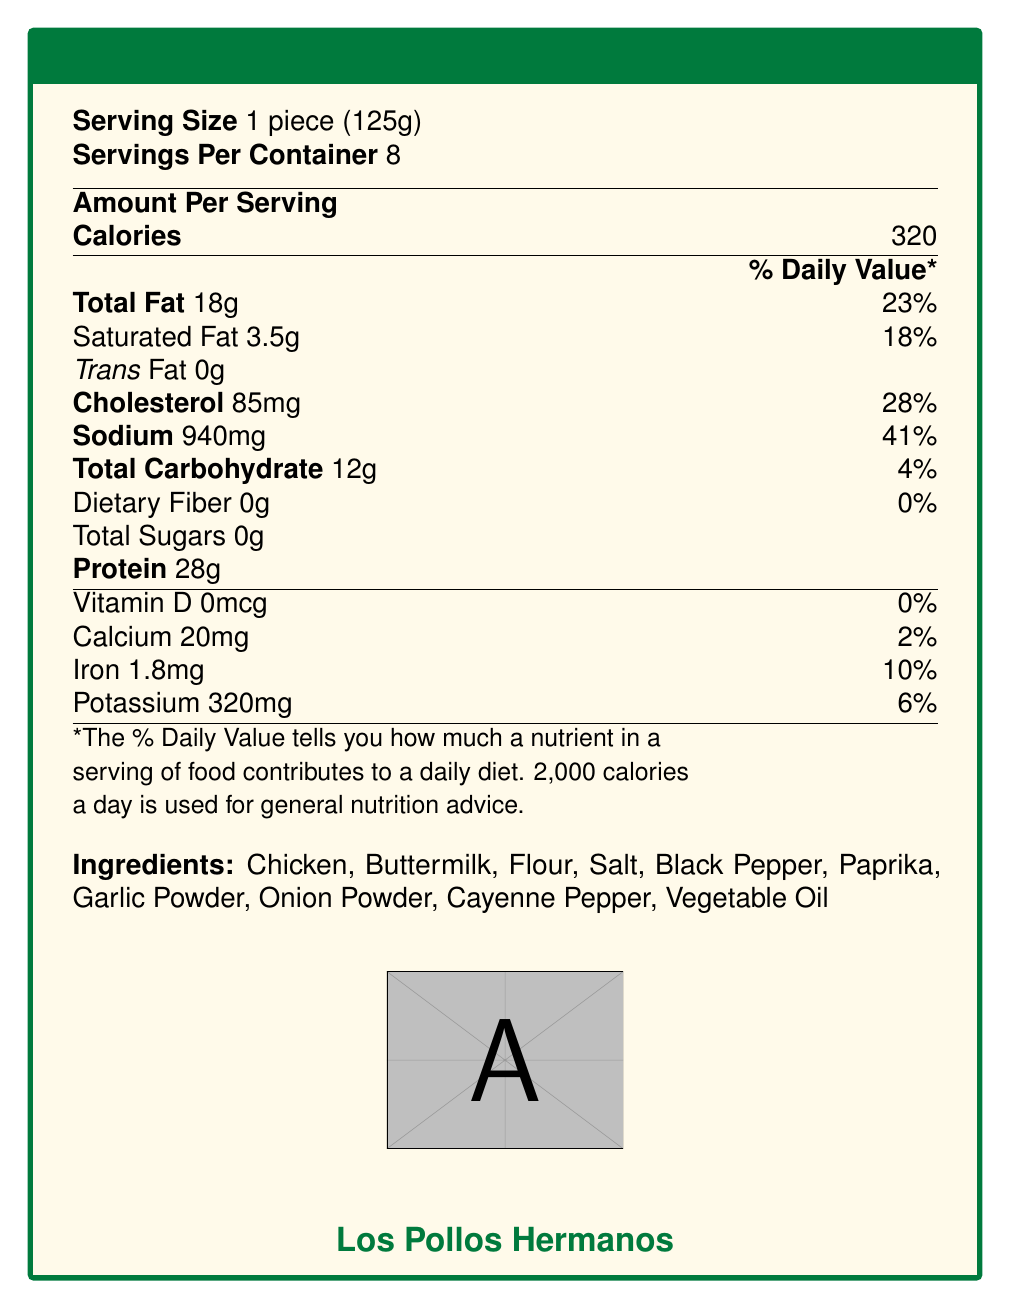What is the serving size mentioned in the document? The document specifies that the serving size is 1 piece (125g).
Answer: 1 piece (125g) How many servings per container are there? The document clearly states that there are 8 servings per container.
Answer: 8 What is the total fat content per serving and its percentage of the daily value? The document lists the total fat content as 18g per serving, which is 23% of the daily value.
Answer: 18g, 23% How much cholesterol is in one serving of the fried chicken? The document notes that one serving contains 85mg of cholesterol.
Answer: 85mg How does the sodium content per serving compare to the daily value percentage? The sodium content is 940mg per serving, which is 41% of the daily value.
Answer: 41% What is the protein content in one serving? The document states that the protein content per serving is 28g.
Answer: 28g How many grams of trans fat are in one serving? The document indicates that there are 0g of trans fat in one serving.
Answer: 0g Which of the following ingredients is NOT in the fried chicken? A. Garlic Powder B. Preservatives C. Cayenne Pepper D. Buttermilk The listed ingredients are Chicken, Buttermilk, Flour, Salt, Black Pepper, Paprika, Garlic Powder, Onion Powder, Cayenne Pepper, and Vegetable Oil. Preservatives are not mentioned.
Answer: B What vitamin is present in the smallest amount or not at all in the chicken? A. Vitamin D B. Calcium C. Iron D. Potassium The document shows that Vitamin D is 0mcg, which is 0% of the daily value.
Answer: A Does the total carbohydrate in one serving exceed 20% of the daily value? Yes/No The document states that the total carbohydrate is 12g, which is only 4% of the daily value.
Answer: No Summarize the main content of the Nutrition Facts Label for Los Pollos Hermanos' signature fried chicken. This summary captures the essential elements of the nutrition facts, including serving size, servings per container, calorie count, major nutritional values, and ingredients.
Answer: The document provides the nutrition facts for Los Pollos Hermanos' signature fried chicken, indicating a serving size of 1 piece (125g) with 8 servings per container. Key nutritional elements include 320 calories, 18g of total fat (23% daily value), 85mg of cholesterol (28% daily value), 940mg of sodium (41% daily value), 12g of total carbohydrate (4% daily value), and 28g of protein. The ingredients listed are Chicken, Buttermilk, Flour, Salt, Black Pepper, Paprika, Garlic Powder, Onion Powder, Cayenne Pepper, and Vegetable Oil. How many milligrams of calcium are in one serving? According to the document, there are 20mg of calcium per serving.
Answer: 20mg What aspect of Gus Fring's character is reflected in the meticulous nutrition facts of the fried chicken? The document notes that the meticulous nutrition information reflects Gus Fring's methodical approach to both his legitimate and illegal businesses.
Answer: Calculation and attention to detail What is the golden-brown hue of the fried chicken intended to symbolize in the cinematography of the show? The document mentions that the golden-brown hue of the fried chicken mirrors the show's iconic desert landscapes and signifies the tension and duality of Gus Fring's character.
Answer: The golden-brown hue symbolizes the desert landscapes and the duality of Gus Fring's character. What is the relationship between the seemingly wholesome product and the illegal activities it conceals? The document indicates that the wholesome nature of the fried chicken contrasts sharply with the illegal activities it conceals.
Answer: Contrast Can you determine the exact type of vegetable oil used in the fried chicken from the document? The document only lists "Vegetable Oil" without specifying the exact type of oil used.
Answer: Cannot be determined 